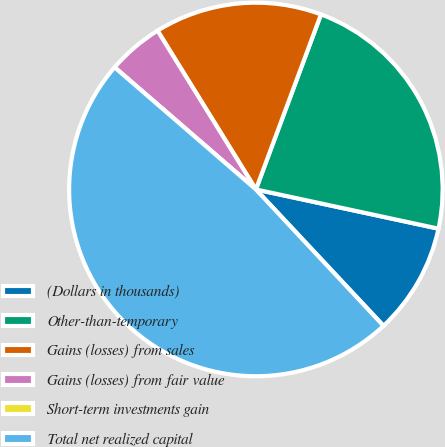Convert chart to OTSL. <chart><loc_0><loc_0><loc_500><loc_500><pie_chart><fcel>(Dollars in thousands)<fcel>Other-than-temporary<fcel>Gains (losses) from sales<fcel>Gains (losses) from fair value<fcel>Short-term investments gain<fcel>Total net realized capital<nl><fcel>9.66%<fcel>22.7%<fcel>14.49%<fcel>4.83%<fcel>0.0%<fcel>48.31%<nl></chart> 